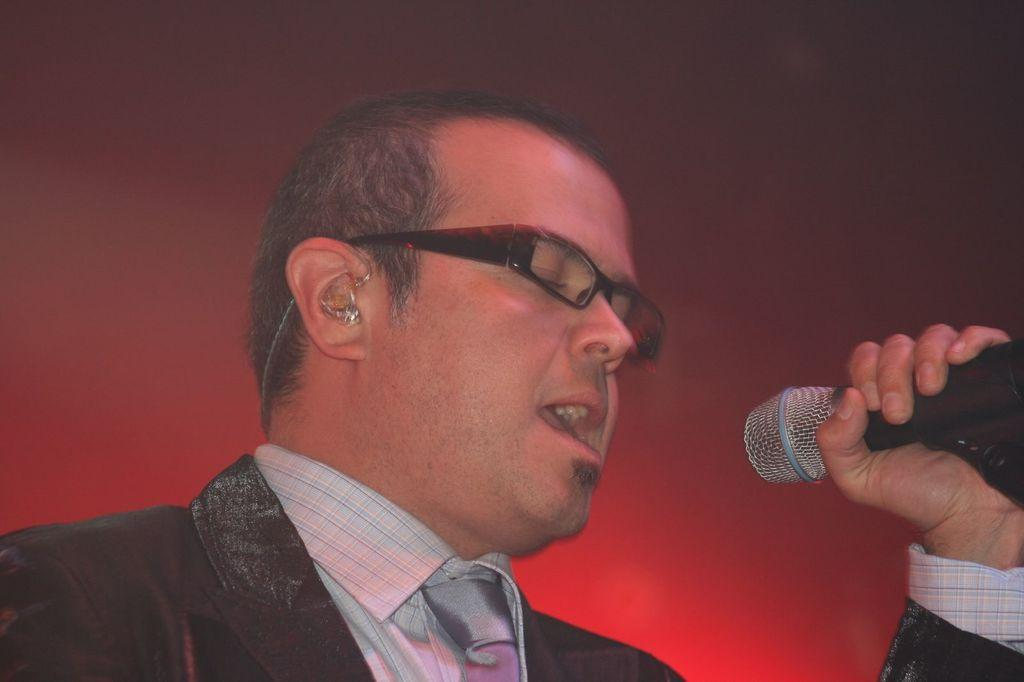What is the main subject of the image? The main subject of the image is a man standing in the center. What is the man holding in the image? The man is holding a microphone. What is the man doing in the image? The man is singing. What type of bottle can be seen in the man's hand in the image? There is no bottle present in the man's hand or in the image. What emotion does the man express towards the audience in the image? The provided facts do not mention any specific emotion expressed by the man; he is simply singing. 